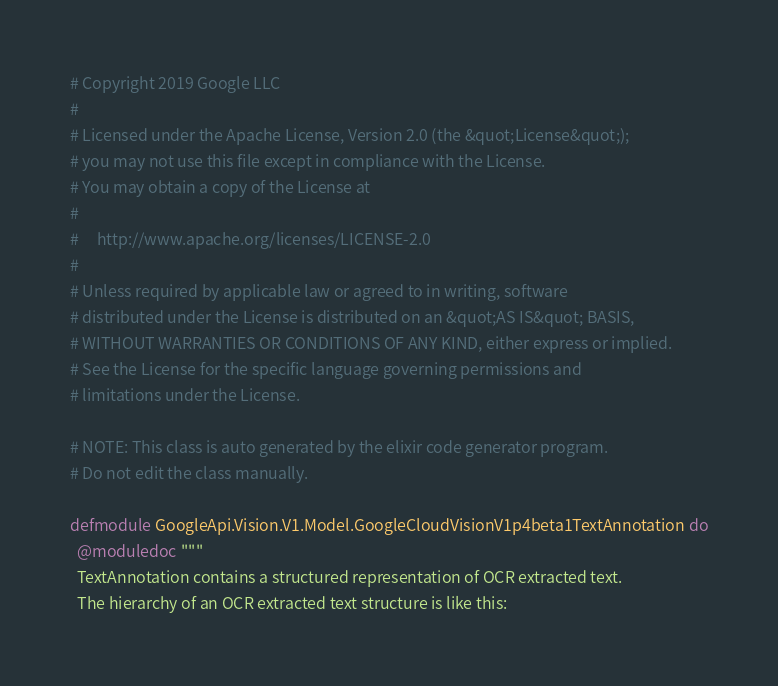<code> <loc_0><loc_0><loc_500><loc_500><_Elixir_># Copyright 2019 Google LLC
#
# Licensed under the Apache License, Version 2.0 (the &quot;License&quot;);
# you may not use this file except in compliance with the License.
# You may obtain a copy of the License at
#
#     http://www.apache.org/licenses/LICENSE-2.0
#
# Unless required by applicable law or agreed to in writing, software
# distributed under the License is distributed on an &quot;AS IS&quot; BASIS,
# WITHOUT WARRANTIES OR CONDITIONS OF ANY KIND, either express or implied.
# See the License for the specific language governing permissions and
# limitations under the License.

# NOTE: This class is auto generated by the elixir code generator program.
# Do not edit the class manually.

defmodule GoogleApi.Vision.V1.Model.GoogleCloudVisionV1p4beta1TextAnnotation do
  @moduledoc """
  TextAnnotation contains a structured representation of OCR extracted text.
  The hierarchy of an OCR extracted text structure is like this:</code> 